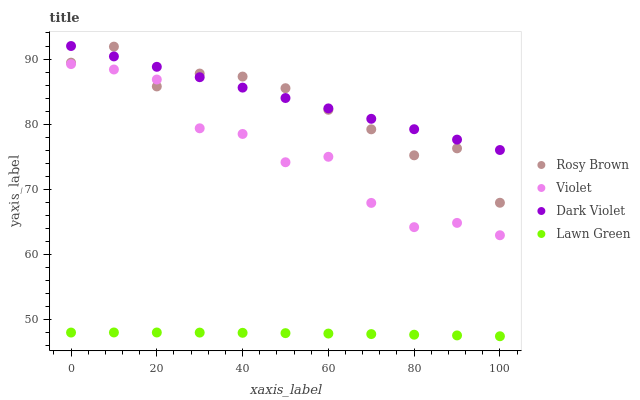Does Lawn Green have the minimum area under the curve?
Answer yes or no. Yes. Does Dark Violet have the maximum area under the curve?
Answer yes or no. Yes. Does Rosy Brown have the minimum area under the curve?
Answer yes or no. No. Does Rosy Brown have the maximum area under the curve?
Answer yes or no. No. Is Dark Violet the smoothest?
Answer yes or no. Yes. Is Violet the roughest?
Answer yes or no. Yes. Is Rosy Brown the smoothest?
Answer yes or no. No. Is Rosy Brown the roughest?
Answer yes or no. No. Does Lawn Green have the lowest value?
Answer yes or no. Yes. Does Rosy Brown have the lowest value?
Answer yes or no. No. Does Dark Violet have the highest value?
Answer yes or no. Yes. Does Rosy Brown have the highest value?
Answer yes or no. No. Is Lawn Green less than Dark Violet?
Answer yes or no. Yes. Is Rosy Brown greater than Lawn Green?
Answer yes or no. Yes. Does Dark Violet intersect Rosy Brown?
Answer yes or no. Yes. Is Dark Violet less than Rosy Brown?
Answer yes or no. No. Is Dark Violet greater than Rosy Brown?
Answer yes or no. No. Does Lawn Green intersect Dark Violet?
Answer yes or no. No. 